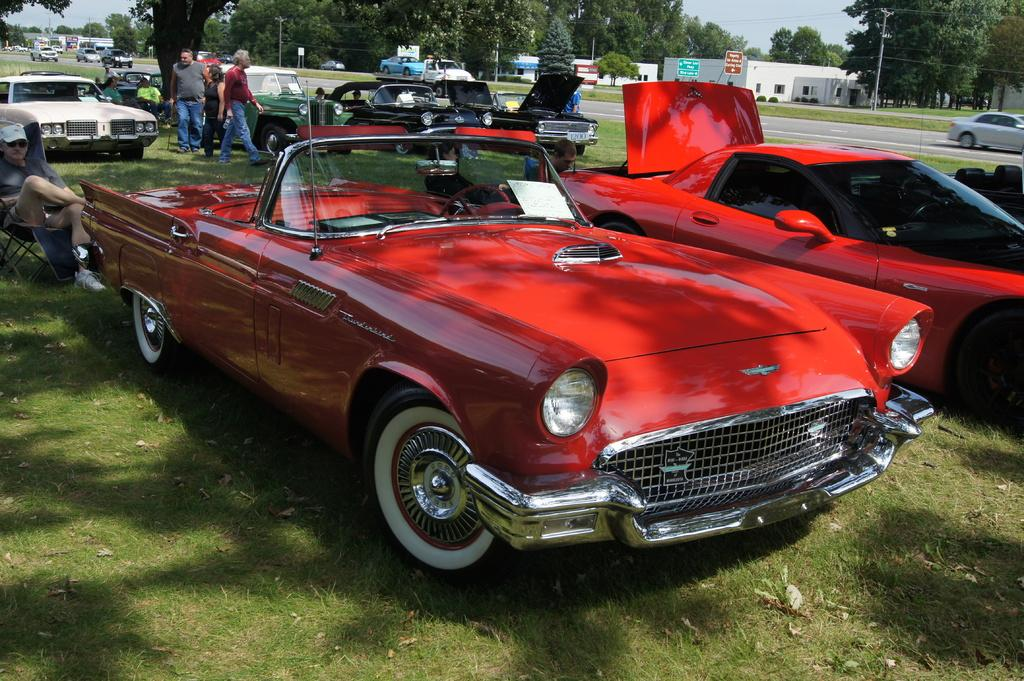What is the main subject in the center of the image? There are cars in the center of the image. Are there any people visible in the image? Yes, there are people standing in the image. Can you describe the man's position in the image? There is a man sitting on the left side of the image. What can be seen in the background of the image? There are trees, buildings, and the sky visible in the background of the image. What type of cabbage is being harvested by the visitor in the image? There is no visitor or cabbage present in the image. 